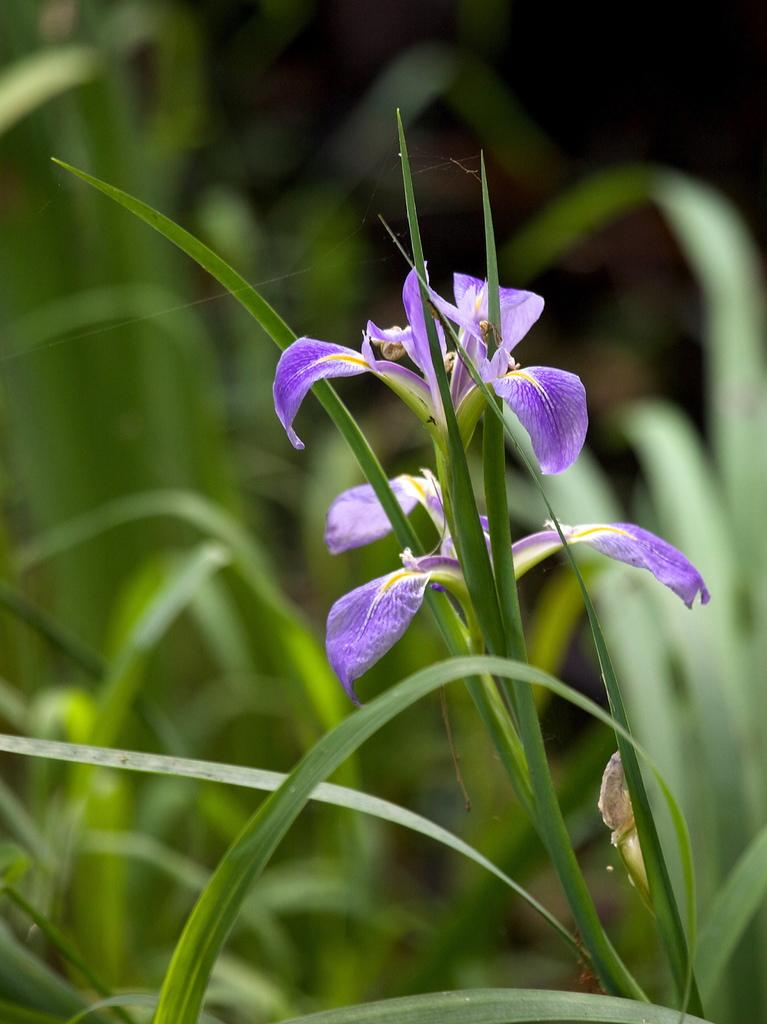What types of living organisms can be seen in the image? There are many plants and flowers in the image. Can you describe the background of the image? The background of the image is blurred. What type of tramp can be seen in the image? There is no tramp present in the image; it features plants and flowers. How does the wound on the flower look in the image? There is no wound on any of the flowers in the image. 